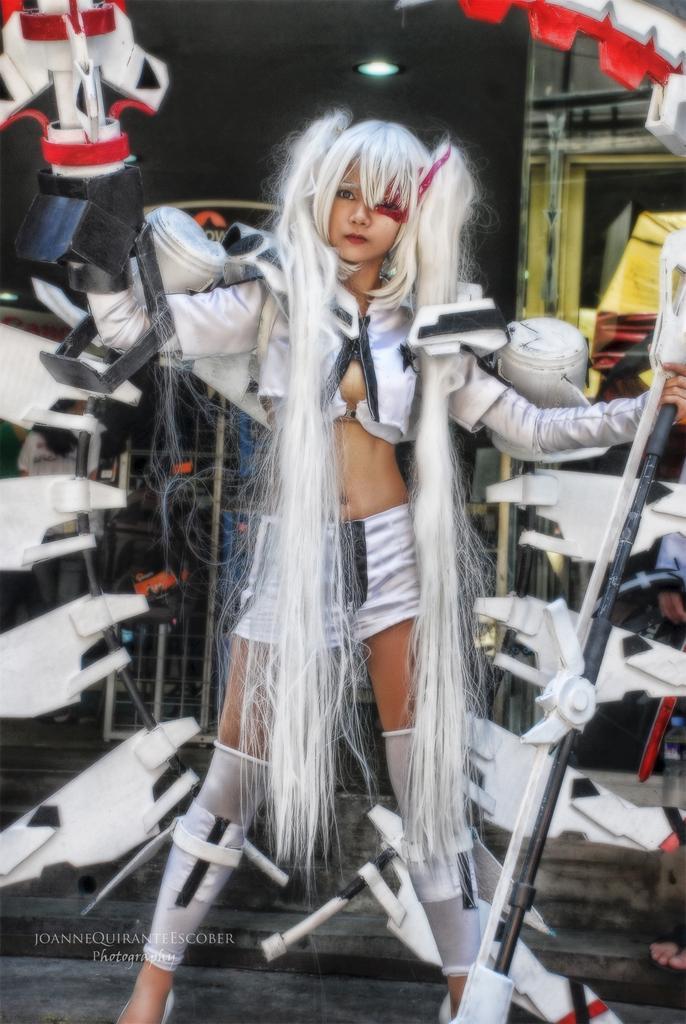Please provide a concise description of this image. In this image we can see a lady wearing different costume, she is holding some objects in her hands, behind her, there are some other objects, also we can see light, and there is a text on the image. 